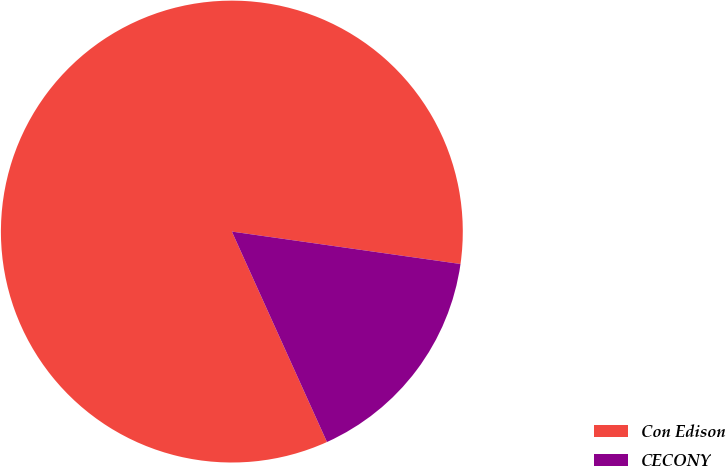Convert chart. <chart><loc_0><loc_0><loc_500><loc_500><pie_chart><fcel>Con Edison<fcel>CECONY<nl><fcel>84.0%<fcel>16.0%<nl></chart> 